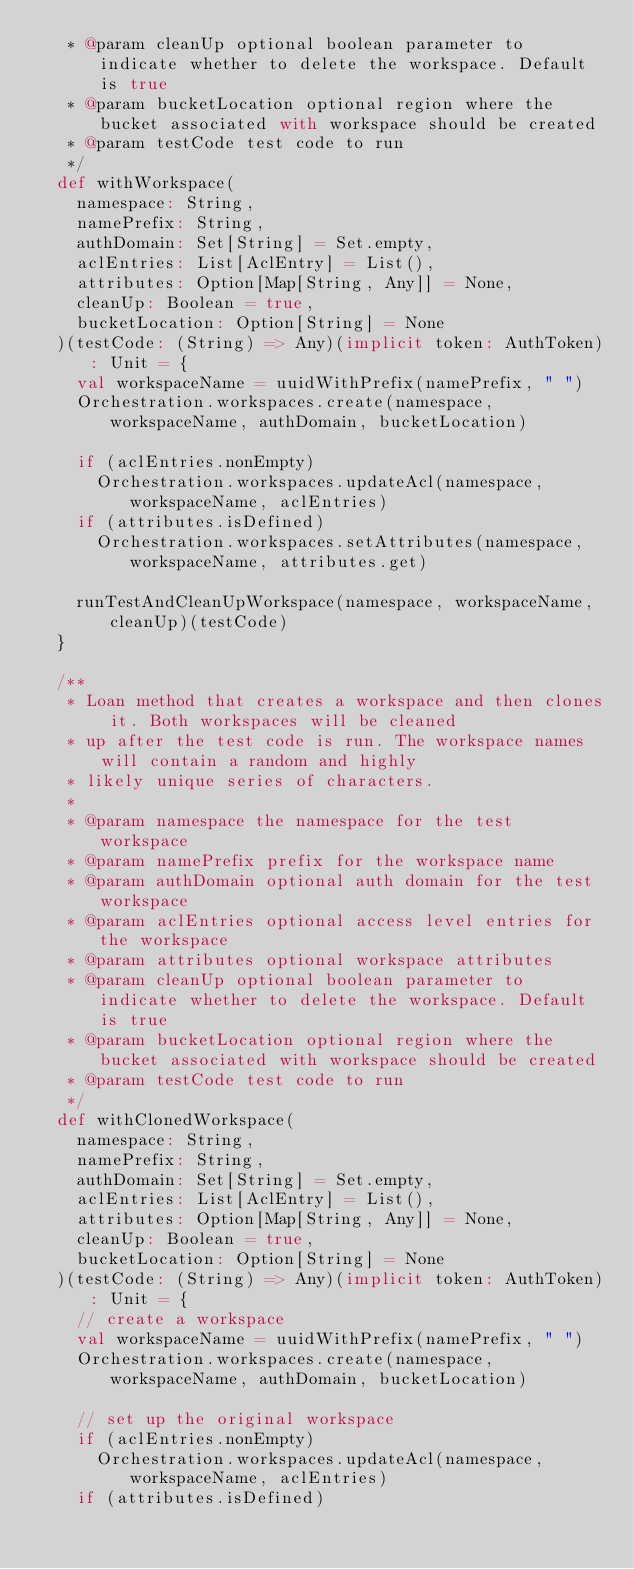Convert code to text. <code><loc_0><loc_0><loc_500><loc_500><_Scala_>   * @param cleanUp optional boolean parameter to indicate whether to delete the workspace. Default is true
   * @param bucketLocation optional region where the bucket associated with workspace should be created
   * @param testCode test code to run
   */
  def withWorkspace(
    namespace: String,
    namePrefix: String,
    authDomain: Set[String] = Set.empty,
    aclEntries: List[AclEntry] = List(),
    attributes: Option[Map[String, Any]] = None,
    cleanUp: Boolean = true,
    bucketLocation: Option[String] = None
  )(testCode: (String) => Any)(implicit token: AuthToken): Unit = {
    val workspaceName = uuidWithPrefix(namePrefix, " ")
    Orchestration.workspaces.create(namespace, workspaceName, authDomain, bucketLocation)

    if (aclEntries.nonEmpty)
      Orchestration.workspaces.updateAcl(namespace, workspaceName, aclEntries)
    if (attributes.isDefined)
      Orchestration.workspaces.setAttributes(namespace, workspaceName, attributes.get)

    runTestAndCleanUpWorkspace(namespace, workspaceName, cleanUp)(testCode)
  }

  /**
   * Loan method that creates a workspace and then clones it. Both workspaces will be cleaned
   * up after the test code is run. The workspace names will contain a random and highly
   * likely unique series of characters.
   *
   * @param namespace the namespace for the test workspace
   * @param namePrefix prefix for the workspace name
   * @param authDomain optional auth domain for the test workspace
   * @param aclEntries optional access level entries for the workspace
   * @param attributes optional workspace attributes
   * @param cleanUp optional boolean parameter to indicate whether to delete the workspace. Default is true
   * @param bucketLocation optional region where the bucket associated with workspace should be created
   * @param testCode test code to run
   */
  def withClonedWorkspace(
    namespace: String,
    namePrefix: String,
    authDomain: Set[String] = Set.empty,
    aclEntries: List[AclEntry] = List(),
    attributes: Option[Map[String, Any]] = None,
    cleanUp: Boolean = true,
    bucketLocation: Option[String] = None
  )(testCode: (String) => Any)(implicit token: AuthToken): Unit = {
    // create a workspace
    val workspaceName = uuidWithPrefix(namePrefix, " ")
    Orchestration.workspaces.create(namespace, workspaceName, authDomain, bucketLocation)

    // set up the original workspace
    if (aclEntries.nonEmpty)
      Orchestration.workspaces.updateAcl(namespace, workspaceName, aclEntries)
    if (attributes.isDefined)</code> 